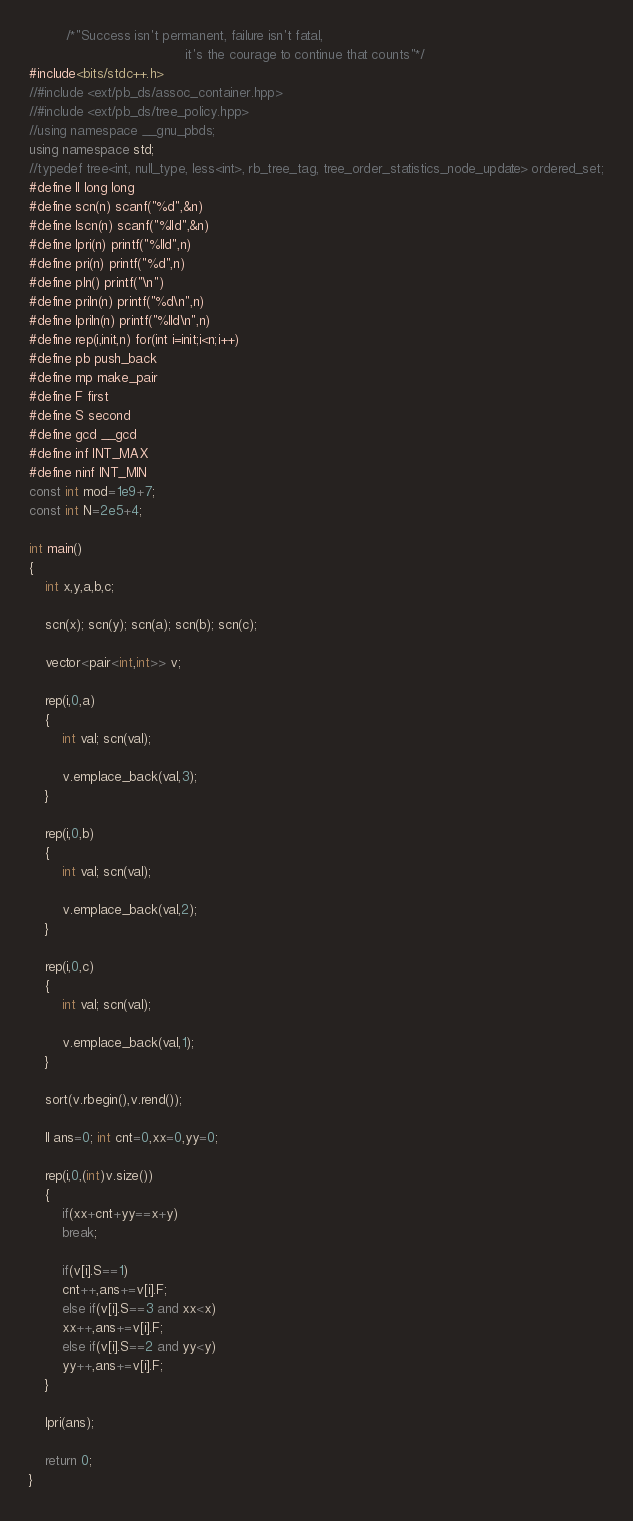<code> <loc_0><loc_0><loc_500><loc_500><_C++_>         /*"Success isn't permanent, failure isn't fatal,
                                      it's the courage to continue that counts"*/
#include<bits/stdc++.h>
//#include <ext/pb_ds/assoc_container.hpp>
//#include <ext/pb_ds/tree_policy.hpp>
//using namespace __gnu_pbds;
using namespace std;
//typedef tree<int, null_type, less<int>, rb_tree_tag, tree_order_statistics_node_update> ordered_set;
#define ll long long 
#define scn(n) scanf("%d",&n)
#define lscn(n) scanf("%lld",&n)
#define lpri(n) printf("%lld",n)
#define pri(n) printf("%d",n)
#define pln() printf("\n")
#define priln(n) printf("%d\n",n)
#define lpriln(n) printf("%lld\n",n)
#define rep(i,init,n) for(int i=init;i<n;i++)
#define pb push_back     
#define mp make_pair
#define F first
#define S second
#define gcd __gcd
#define inf INT_MAX
#define ninf INT_MIN
const int mod=1e9+7;         
const int N=2e5+4;

int main()
{
	int x,y,a,b,c;

	scn(x); scn(y); scn(a); scn(b); scn(c);

	vector<pair<int,int>> v;

	rep(i,0,a)
	{
		int val; scn(val);

		v.emplace_back(val,3);
	}

	rep(i,0,b)
	{
		int val; scn(val);

		v.emplace_back(val,2);
	}

	rep(i,0,c)
	{
		int val; scn(val);

		v.emplace_back(val,1);
	}

	sort(v.rbegin(),v.rend());

	ll ans=0; int cnt=0,xx=0,yy=0;

	rep(i,0,(int)v.size())
	{
		if(xx+cnt+yy==x+y)
		break;

		if(v[i].S==1)
		cnt++,ans+=v[i].F;
		else if(v[i].S==3 and xx<x)
		xx++,ans+=v[i].F;
		else if(v[i].S==2 and yy<y)
		yy++,ans+=v[i].F;
	}

	lpri(ans);

    return 0;
}</code> 